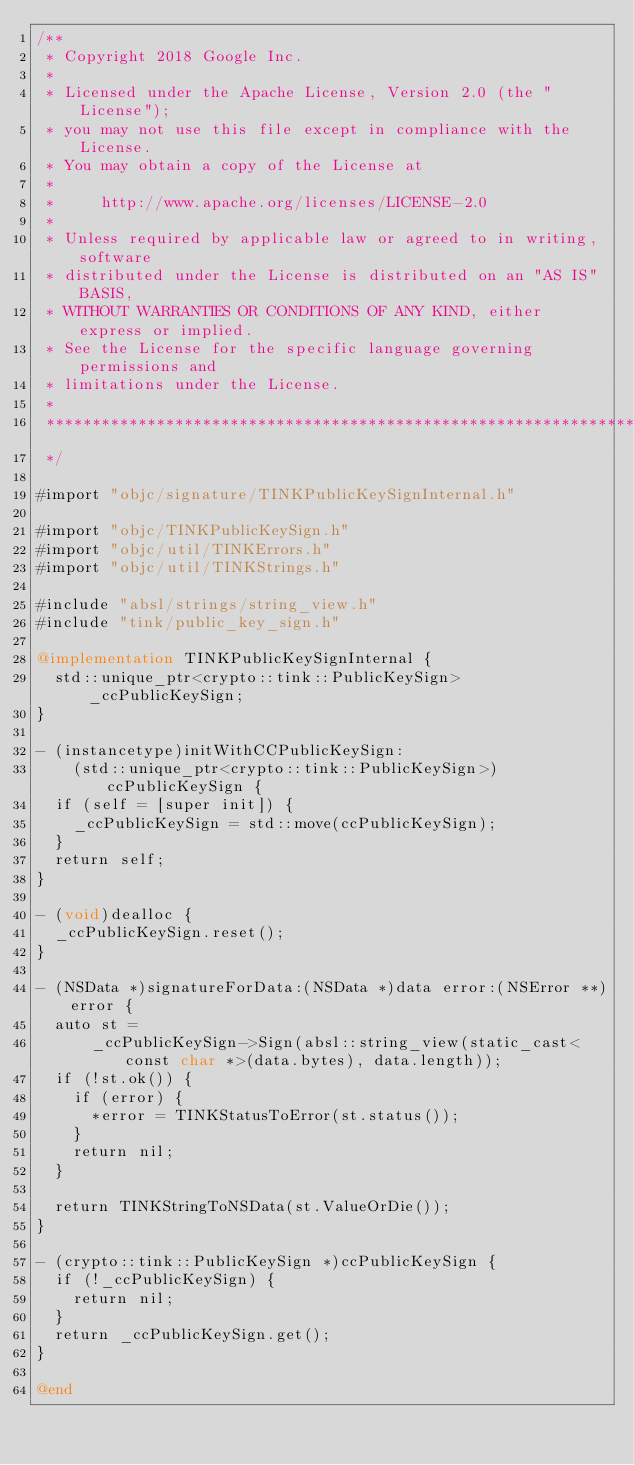Convert code to text. <code><loc_0><loc_0><loc_500><loc_500><_ObjectiveC_>/**
 * Copyright 2018 Google Inc.
 *
 * Licensed under the Apache License, Version 2.0 (the "License");
 * you may not use this file except in compliance with the License.
 * You may obtain a copy of the License at
 *
 *     http://www.apache.org/licenses/LICENSE-2.0
 *
 * Unless required by applicable law or agreed to in writing, software
 * distributed under the License is distributed on an "AS IS" BASIS,
 * WITHOUT WARRANTIES OR CONDITIONS OF ANY KIND, either express or implied.
 * See the License for the specific language governing permissions and
 * limitations under the License.
 *
 **************************************************************************
 */

#import "objc/signature/TINKPublicKeySignInternal.h"

#import "objc/TINKPublicKeySign.h"
#import "objc/util/TINKErrors.h"
#import "objc/util/TINKStrings.h"

#include "absl/strings/string_view.h"
#include "tink/public_key_sign.h"

@implementation TINKPublicKeySignInternal {
  std::unique_ptr<crypto::tink::PublicKeySign> _ccPublicKeySign;
}

- (instancetype)initWithCCPublicKeySign:
    (std::unique_ptr<crypto::tink::PublicKeySign>)ccPublicKeySign {
  if (self = [super init]) {
    _ccPublicKeySign = std::move(ccPublicKeySign);
  }
  return self;
}

- (void)dealloc {
  _ccPublicKeySign.reset();
}

- (NSData *)signatureForData:(NSData *)data error:(NSError **)error {
  auto st =
      _ccPublicKeySign->Sign(absl::string_view(static_cast<const char *>(data.bytes), data.length));
  if (!st.ok()) {
    if (error) {
      *error = TINKStatusToError(st.status());
    }
    return nil;
  }

  return TINKStringToNSData(st.ValueOrDie());
}

- (crypto::tink::PublicKeySign *)ccPublicKeySign {
  if (!_ccPublicKeySign) {
    return nil;
  }
  return _ccPublicKeySign.get();
}

@end
</code> 